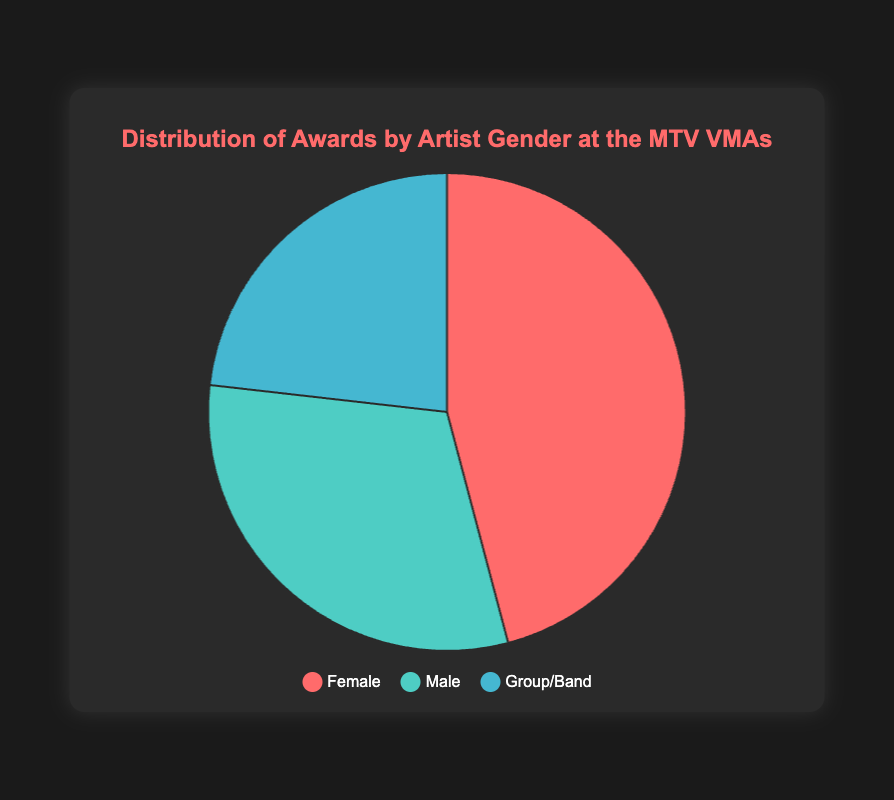Which gender category has the highest number of awards? The chart shows three gender categories: Female, Male, and Group/Band. By inspecting the pie chart segments, we can identify which one occupies the largest proportion.
Answer: Female How many more awards have been won by Female artists compared to Male artists? First, identify the total number of awards for Female (20 + 24 + 18 + 14 + 13 = 89) and Male (16 + 15 + 12 + 10 + 7 = 60). Then, subtract the total number of awards for Male from Female (89 - 60).
Answer: 29 What percentage of total awards have been won by Group/Band artists? The total number of awards across all categories is calculated by summing the awards for Female (89), Male (60), and Group/Band (7 + 11 + 10 + 9 + 8 = 45). The total is 194. The percentage is then calculated as (45 / 194) * 100.
Answer: 23.2% Which artist has won the most awards overall? By inspecting the artists listed in each gender category and comparing their individual award counts, we can determine the artist with the highest count. Beyoncé, from the Female category, has the most awards.
Answer: Beyoncé Do Male artists collectively have more awards than Group/Band artists? Sum the awards for Male (60) and Group/Band categories (45). Then compare the totals to determine which is higher.
Answer: Yes How much larger is the Female segment compared to the Group/Band segment in the pie chart? Find the total number of awards for Female (89) and Group/Band (45). Subtract the number for Group/Band from Female (89 - 45).
Answer: 44 Combine the awards for all artists named with an "S" in their name. What is the total? Identify artists with an "S" in their names: Taylor Swift (14), Justin Timberlake (10), NSYNC (9). Sum their awards (14 + 10 + 9).
Answer: 33 If we exclude Beyoncé, who is the next highest award-winning artist among all categories? Excluding Beyoncé (24), compare the highest awards among other artists: Madonna (20), Michael Jackson (16), Green Day (11). Madonna has the next highest count.
Answer: Madonna What color represents the Male category in the pie chart, and what is its significance? The Male category is represented by the color greenish-blue. This signifies the awards won by Male artists.
Answer: Greenish-blue 